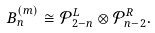<formula> <loc_0><loc_0><loc_500><loc_500>B ^ { ( m ) } _ { n } \cong \mathcal { P } _ { 2 - n } ^ { L } \otimes \mathcal { P } _ { n - 2 } ^ { R } .</formula> 